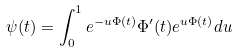Convert formula to latex. <formula><loc_0><loc_0><loc_500><loc_500>\psi ( t ) = \int _ { 0 } ^ { 1 } e ^ { - u \Phi ( t ) } \Phi ^ { \prime } ( t ) e ^ { u \Phi ( t ) } d u</formula> 